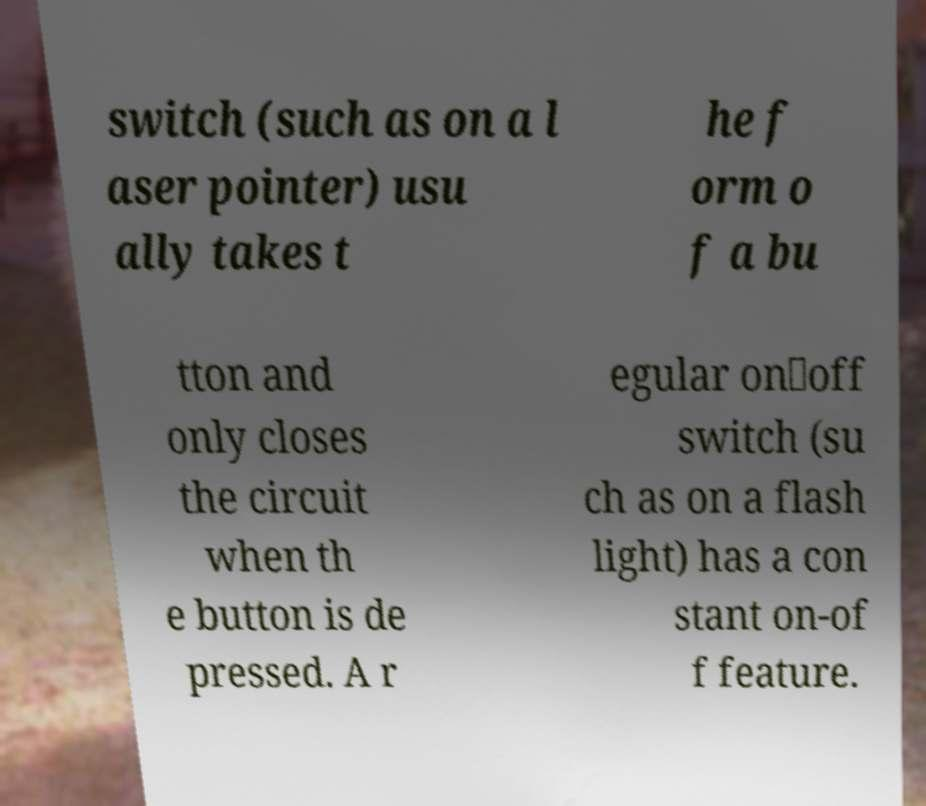For documentation purposes, I need the text within this image transcribed. Could you provide that? switch (such as on a l aser pointer) usu ally takes t he f orm o f a bu tton and only closes the circuit when th e button is de pressed. A r egular on‑off switch (su ch as on a flash light) has a con stant on-of f feature. 